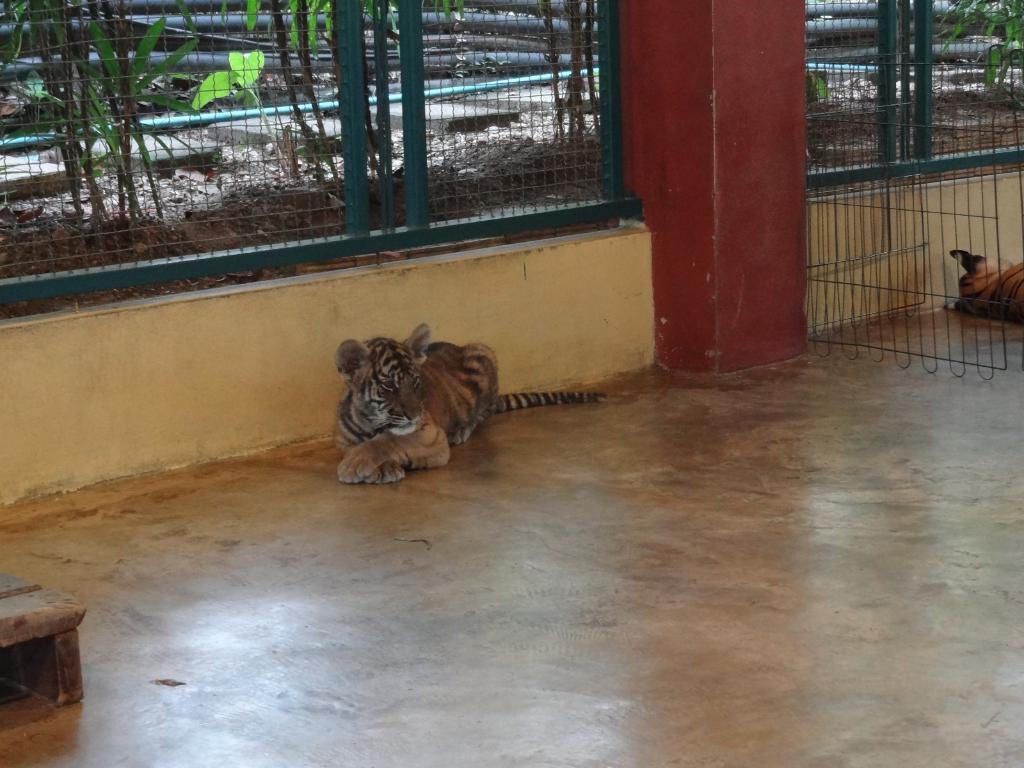Could you give a brief overview of what you see in this image? In this picture we can see tigers, floor and fences, through fences we can see leaves and objects. 